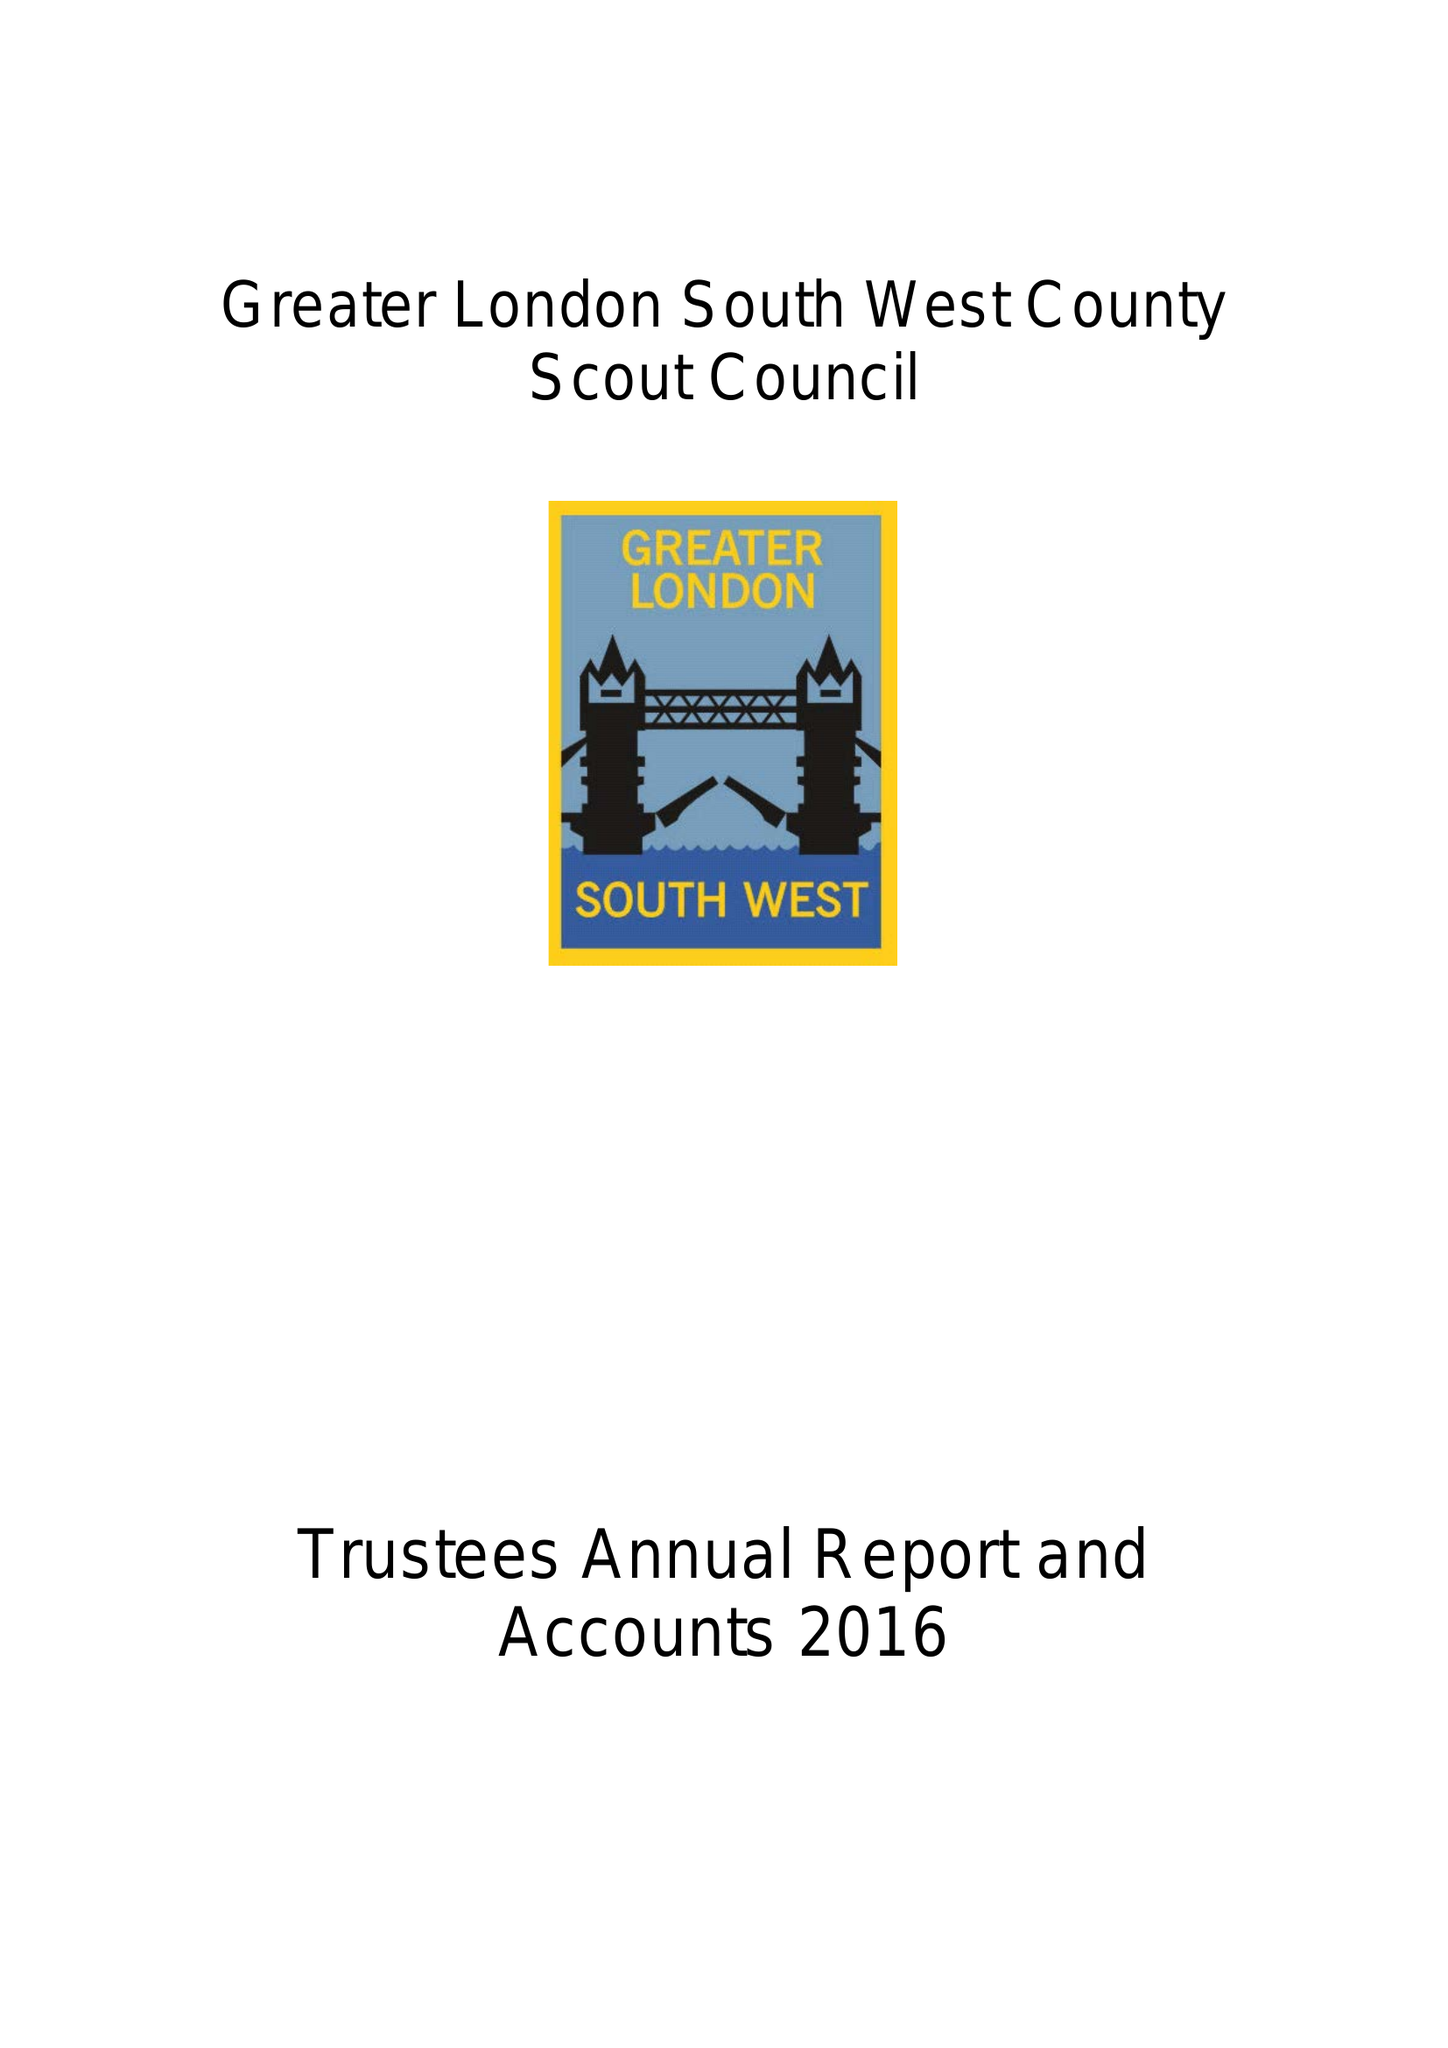What is the value for the report_date?
Answer the question using a single word or phrase. 2016-12-31 